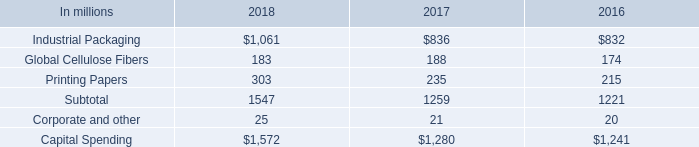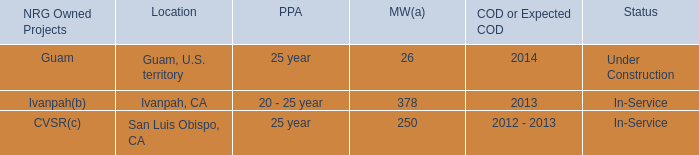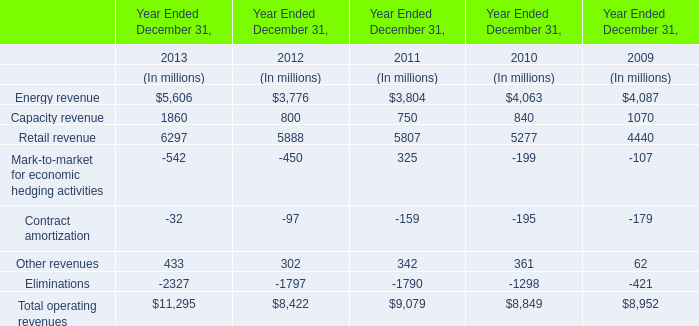How much of Total operating revenues is there in total in 2013 without Energy revenue and Retail revenue? (in million) 
Computations: ((11295 - 5606) - 6297)
Answer: -608.0. 